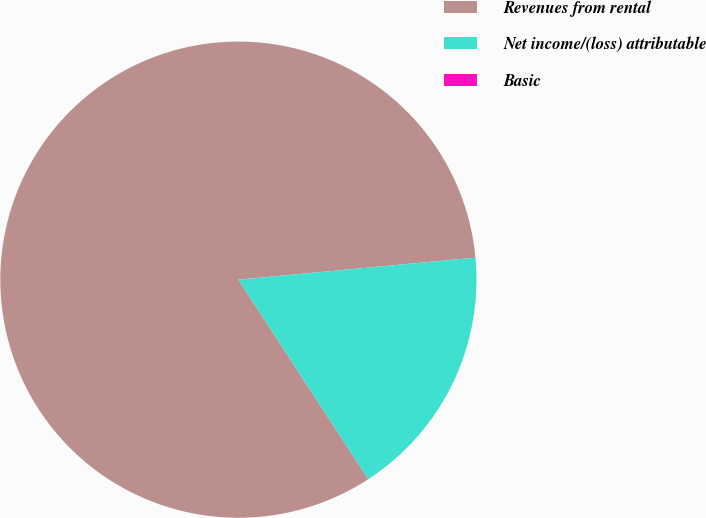Convert chart. <chart><loc_0><loc_0><loc_500><loc_500><pie_chart><fcel>Revenues from rental<fcel>Net income/(loss) attributable<fcel>Basic<nl><fcel>82.71%<fcel>17.29%<fcel>0.0%<nl></chart> 